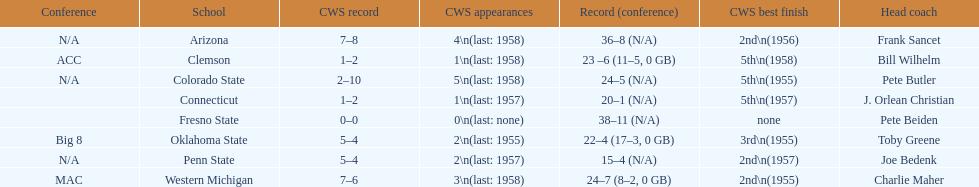List each of the schools that came in 2nd for cws best finish. Arizona, Penn State, Western Michigan. 